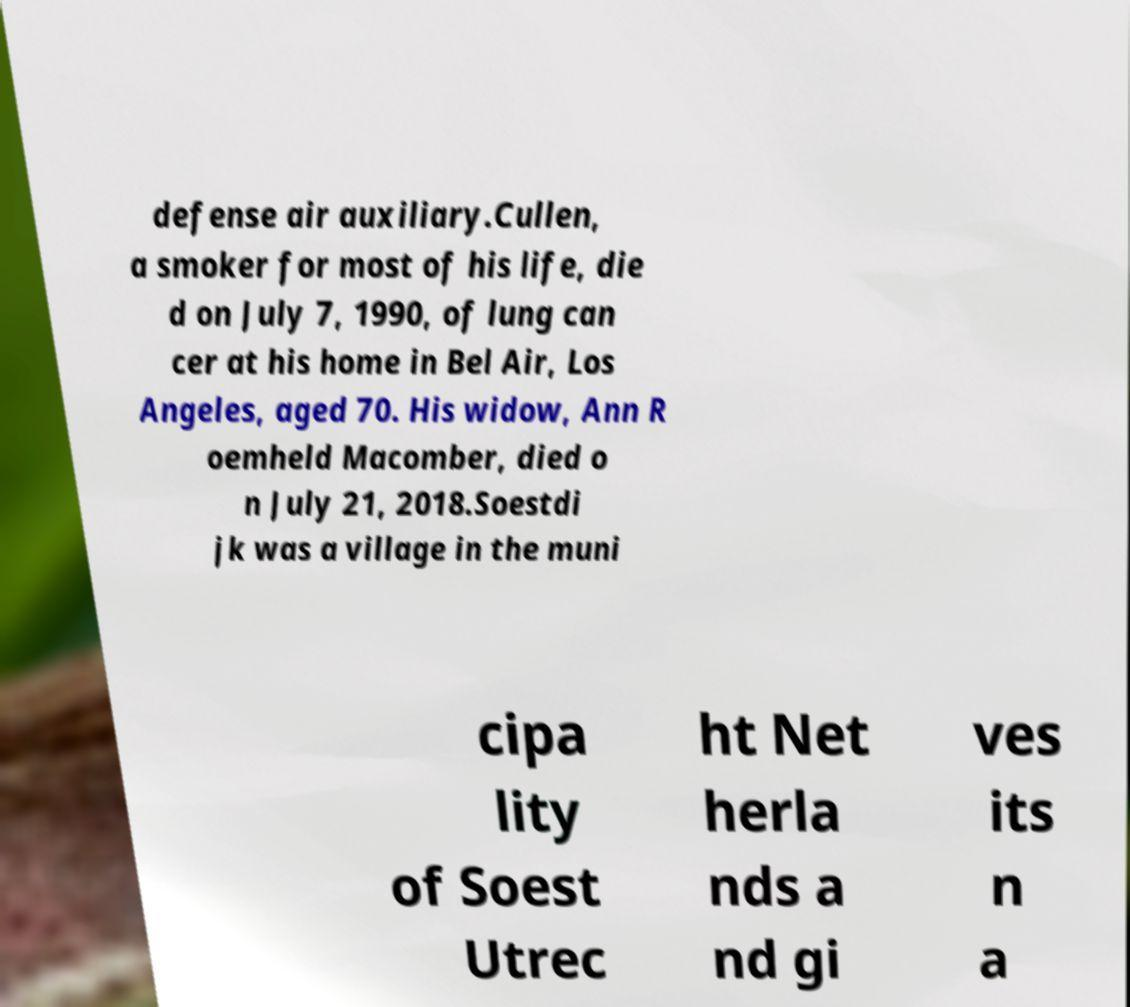I need the written content from this picture converted into text. Can you do that? defense air auxiliary.Cullen, a smoker for most of his life, die d on July 7, 1990, of lung can cer at his home in Bel Air, Los Angeles, aged 70. His widow, Ann R oemheld Macomber, died o n July 21, 2018.Soestdi jk was a village in the muni cipa lity of Soest Utrec ht Net herla nds a nd gi ves its n a 